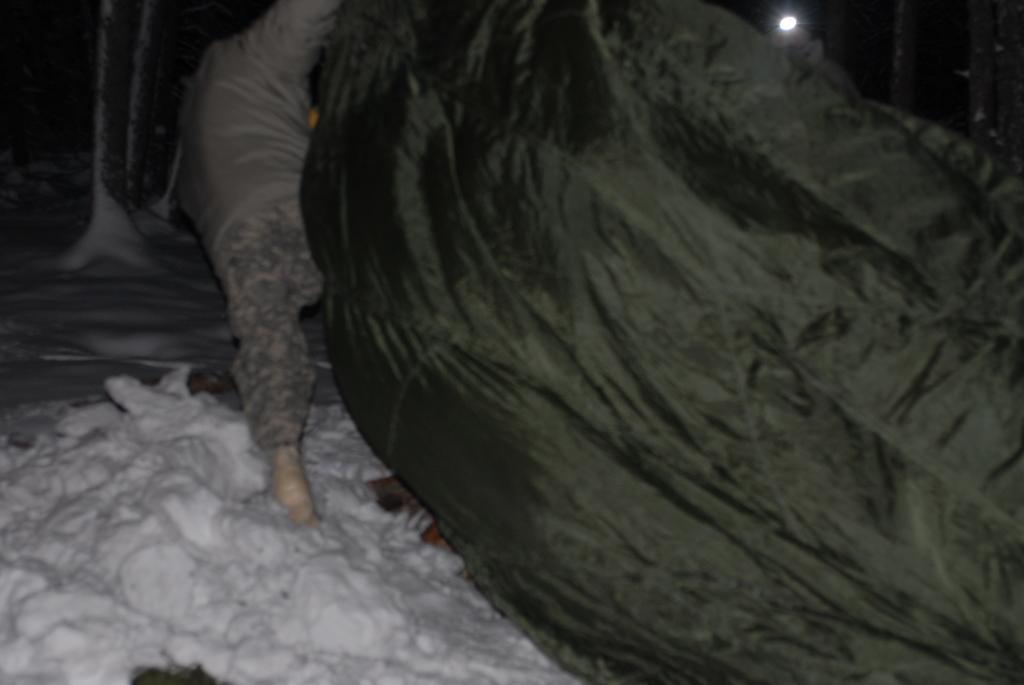Can you describe this image briefly? There is a person standing on the snow surface, near a black color cover. In the background, there is a light and there are other objects. 